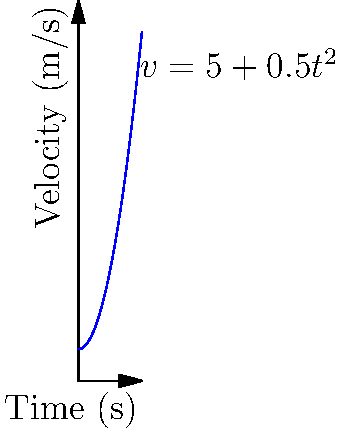In a film production, a special camera is used to capture high-speed sequences. The velocity-time graph of the film reel is shown above, where the velocity (in m/s) is given by the function $v(t) = 5 + 0.5t^2$, and $t$ is time in seconds. At what time is the acceleration of the film reel equal to 5 m/s²? To solve this problem, we need to follow these steps:

1) The acceleration is the rate of change of velocity with respect to time. In calculus terms, this is the derivative of the velocity function.

2) Given: $v(t) = 5 + 0.5t^2$

3) To find the acceleration function, we need to differentiate $v(t)$ with respect to $t$:
   
   $a(t) = \frac{d}{dt}v(t) = \frac{d}{dt}(5 + 0.5t^2) = 0 + 0.5 \cdot 2t = t$

4) Now we have the acceleration function: $a(t) = t$

5) We want to find when $a(t) = 5$ m/s²:
   
   $t = 5$

6) Therefore, the acceleration of the film reel is equal to 5 m/s² when $t = 5$ seconds.
Answer: 5 seconds 